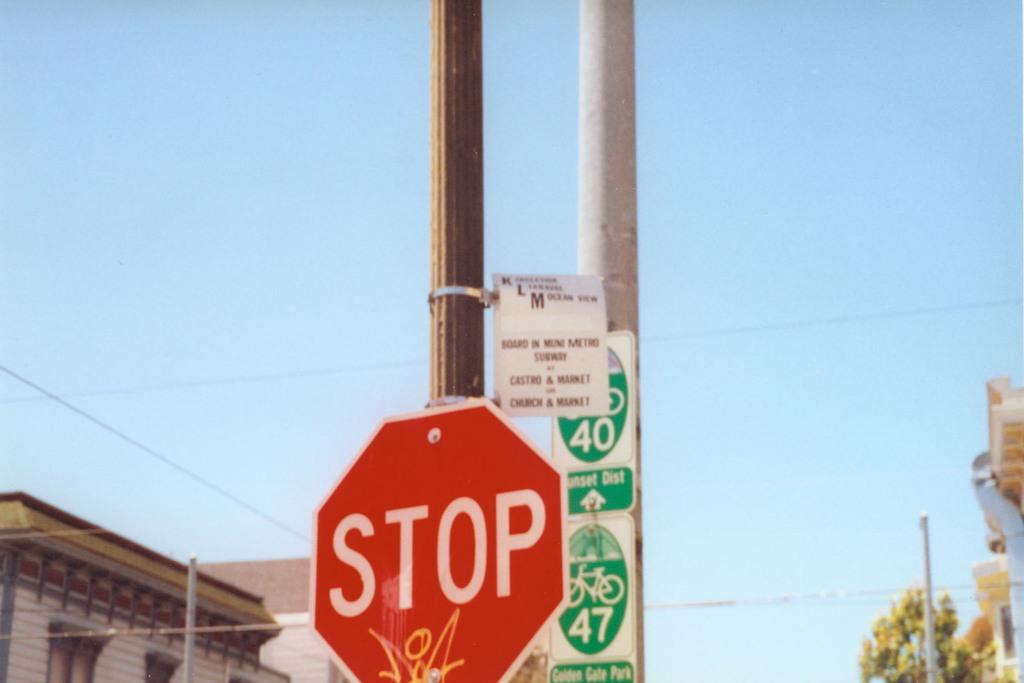<image>
Describe the image concisely. a stop sign that is outside with many things around it 